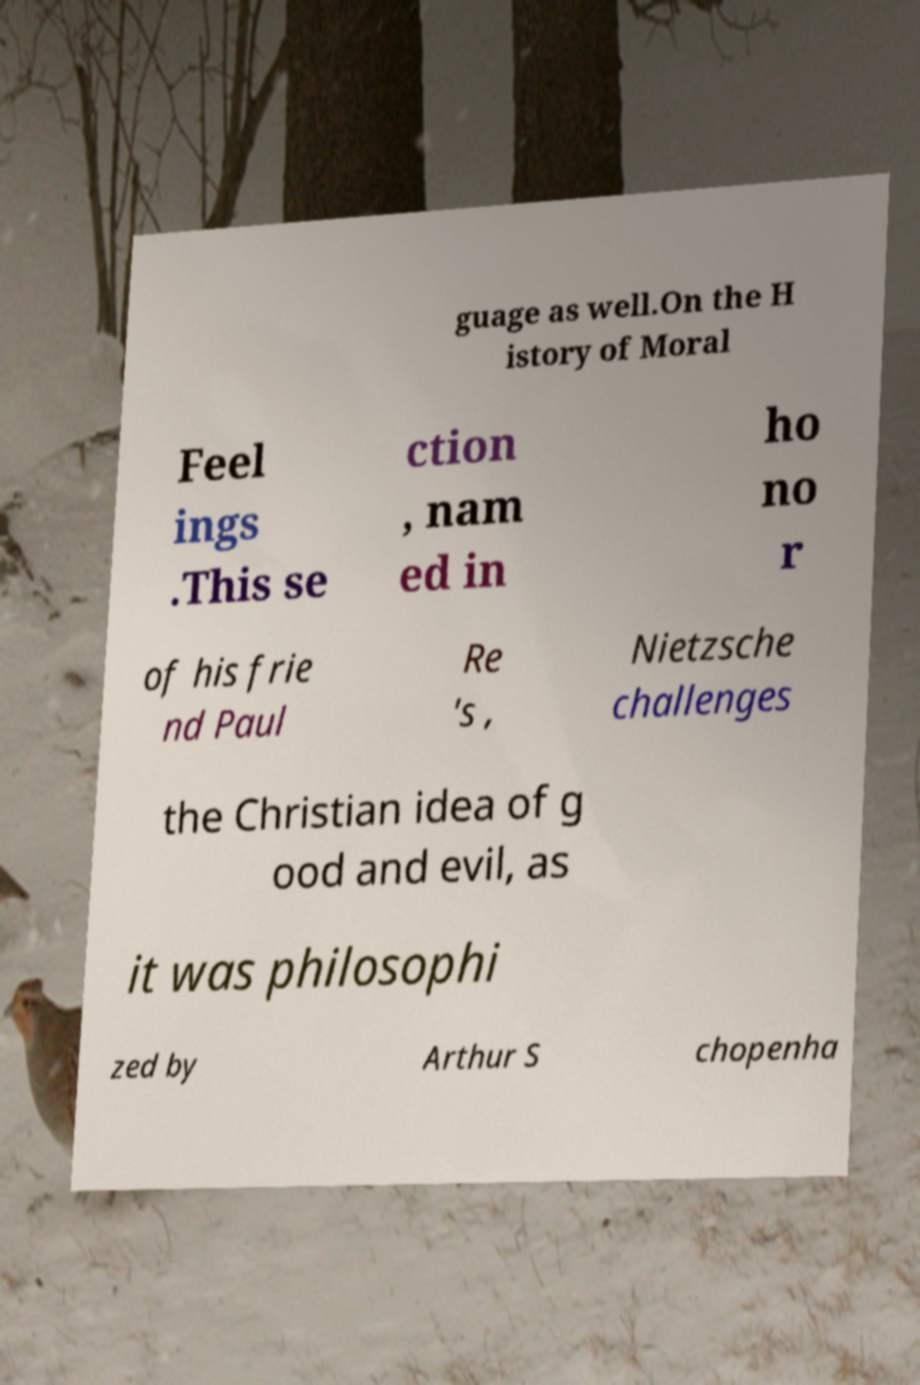There's text embedded in this image that I need extracted. Can you transcribe it verbatim? guage as well.On the H istory of Moral Feel ings .This se ction , nam ed in ho no r of his frie nd Paul Re 's , Nietzsche challenges the Christian idea of g ood and evil, as it was philosophi zed by Arthur S chopenha 